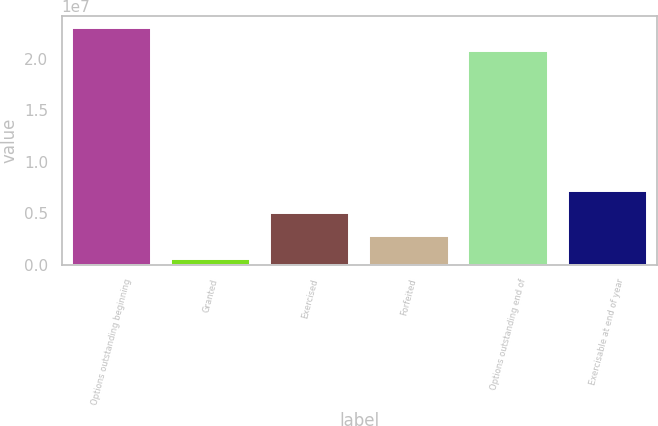Convert chart. <chart><loc_0><loc_0><loc_500><loc_500><bar_chart><fcel>Options outstanding beginning<fcel>Granted<fcel>Exercised<fcel>Forfeited<fcel>Options outstanding end of<fcel>Exercisable at end of year<nl><fcel>2.30505e+07<fcel>532088<fcel>4.97519e+06<fcel>2.75364e+06<fcel>2.08289e+07<fcel>7.19674e+06<nl></chart> 